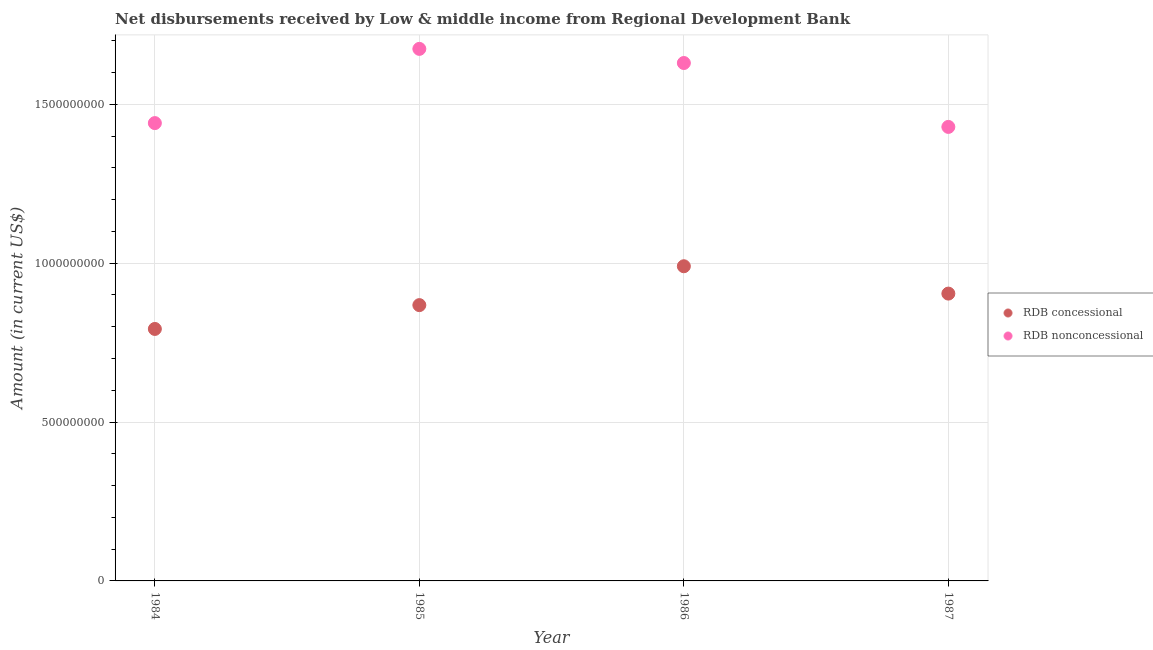How many different coloured dotlines are there?
Ensure brevity in your answer.  2. What is the net concessional disbursements from rdb in 1986?
Your response must be concise. 9.90e+08. Across all years, what is the maximum net concessional disbursements from rdb?
Your answer should be very brief. 9.90e+08. Across all years, what is the minimum net concessional disbursements from rdb?
Keep it short and to the point. 7.93e+08. In which year was the net concessional disbursements from rdb minimum?
Your response must be concise. 1984. What is the total net non concessional disbursements from rdb in the graph?
Your answer should be compact. 6.17e+09. What is the difference between the net non concessional disbursements from rdb in 1984 and that in 1985?
Provide a short and direct response. -2.34e+08. What is the difference between the net non concessional disbursements from rdb in 1987 and the net concessional disbursements from rdb in 1984?
Give a very brief answer. 6.36e+08. What is the average net non concessional disbursements from rdb per year?
Provide a short and direct response. 1.54e+09. In the year 1984, what is the difference between the net concessional disbursements from rdb and net non concessional disbursements from rdb?
Make the answer very short. -6.48e+08. What is the ratio of the net concessional disbursements from rdb in 1984 to that in 1986?
Give a very brief answer. 0.8. Is the difference between the net concessional disbursements from rdb in 1984 and 1987 greater than the difference between the net non concessional disbursements from rdb in 1984 and 1987?
Ensure brevity in your answer.  No. What is the difference between the highest and the second highest net non concessional disbursements from rdb?
Make the answer very short. 4.45e+07. What is the difference between the highest and the lowest net concessional disbursements from rdb?
Make the answer very short. 1.97e+08. Is the net non concessional disbursements from rdb strictly greater than the net concessional disbursements from rdb over the years?
Ensure brevity in your answer.  Yes. Is the net non concessional disbursements from rdb strictly less than the net concessional disbursements from rdb over the years?
Give a very brief answer. No. How many dotlines are there?
Make the answer very short. 2. What is the difference between two consecutive major ticks on the Y-axis?
Provide a succinct answer. 5.00e+08. Are the values on the major ticks of Y-axis written in scientific E-notation?
Make the answer very short. No. Does the graph contain grids?
Offer a terse response. Yes. Where does the legend appear in the graph?
Ensure brevity in your answer.  Center right. What is the title of the graph?
Ensure brevity in your answer.  Net disbursements received by Low & middle income from Regional Development Bank. What is the label or title of the X-axis?
Offer a terse response. Year. What is the label or title of the Y-axis?
Offer a terse response. Amount (in current US$). What is the Amount (in current US$) in RDB concessional in 1984?
Ensure brevity in your answer.  7.93e+08. What is the Amount (in current US$) in RDB nonconcessional in 1984?
Your response must be concise. 1.44e+09. What is the Amount (in current US$) of RDB concessional in 1985?
Make the answer very short. 8.68e+08. What is the Amount (in current US$) in RDB nonconcessional in 1985?
Make the answer very short. 1.67e+09. What is the Amount (in current US$) in RDB concessional in 1986?
Offer a very short reply. 9.90e+08. What is the Amount (in current US$) in RDB nonconcessional in 1986?
Offer a very short reply. 1.63e+09. What is the Amount (in current US$) in RDB concessional in 1987?
Give a very brief answer. 9.04e+08. What is the Amount (in current US$) of RDB nonconcessional in 1987?
Your response must be concise. 1.43e+09. Across all years, what is the maximum Amount (in current US$) of RDB concessional?
Ensure brevity in your answer.  9.90e+08. Across all years, what is the maximum Amount (in current US$) in RDB nonconcessional?
Provide a short and direct response. 1.67e+09. Across all years, what is the minimum Amount (in current US$) in RDB concessional?
Your answer should be very brief. 7.93e+08. Across all years, what is the minimum Amount (in current US$) in RDB nonconcessional?
Your answer should be compact. 1.43e+09. What is the total Amount (in current US$) in RDB concessional in the graph?
Ensure brevity in your answer.  3.56e+09. What is the total Amount (in current US$) in RDB nonconcessional in the graph?
Give a very brief answer. 6.17e+09. What is the difference between the Amount (in current US$) of RDB concessional in 1984 and that in 1985?
Give a very brief answer. -7.50e+07. What is the difference between the Amount (in current US$) in RDB nonconcessional in 1984 and that in 1985?
Offer a terse response. -2.34e+08. What is the difference between the Amount (in current US$) of RDB concessional in 1984 and that in 1986?
Provide a short and direct response. -1.97e+08. What is the difference between the Amount (in current US$) of RDB nonconcessional in 1984 and that in 1986?
Keep it short and to the point. -1.89e+08. What is the difference between the Amount (in current US$) in RDB concessional in 1984 and that in 1987?
Keep it short and to the point. -1.11e+08. What is the difference between the Amount (in current US$) in RDB nonconcessional in 1984 and that in 1987?
Your answer should be compact. 1.20e+07. What is the difference between the Amount (in current US$) of RDB concessional in 1985 and that in 1986?
Keep it short and to the point. -1.22e+08. What is the difference between the Amount (in current US$) of RDB nonconcessional in 1985 and that in 1986?
Give a very brief answer. 4.45e+07. What is the difference between the Amount (in current US$) in RDB concessional in 1985 and that in 1987?
Keep it short and to the point. -3.63e+07. What is the difference between the Amount (in current US$) in RDB nonconcessional in 1985 and that in 1987?
Offer a very short reply. 2.46e+08. What is the difference between the Amount (in current US$) in RDB concessional in 1986 and that in 1987?
Keep it short and to the point. 8.61e+07. What is the difference between the Amount (in current US$) in RDB nonconcessional in 1986 and that in 1987?
Keep it short and to the point. 2.01e+08. What is the difference between the Amount (in current US$) in RDB concessional in 1984 and the Amount (in current US$) in RDB nonconcessional in 1985?
Offer a very short reply. -8.81e+08. What is the difference between the Amount (in current US$) of RDB concessional in 1984 and the Amount (in current US$) of RDB nonconcessional in 1986?
Keep it short and to the point. -8.37e+08. What is the difference between the Amount (in current US$) in RDB concessional in 1984 and the Amount (in current US$) in RDB nonconcessional in 1987?
Offer a very short reply. -6.36e+08. What is the difference between the Amount (in current US$) of RDB concessional in 1985 and the Amount (in current US$) of RDB nonconcessional in 1986?
Make the answer very short. -7.62e+08. What is the difference between the Amount (in current US$) in RDB concessional in 1985 and the Amount (in current US$) in RDB nonconcessional in 1987?
Your answer should be very brief. -5.61e+08. What is the difference between the Amount (in current US$) in RDB concessional in 1986 and the Amount (in current US$) in RDB nonconcessional in 1987?
Keep it short and to the point. -4.38e+08. What is the average Amount (in current US$) of RDB concessional per year?
Your answer should be compact. 8.89e+08. What is the average Amount (in current US$) of RDB nonconcessional per year?
Provide a succinct answer. 1.54e+09. In the year 1984, what is the difference between the Amount (in current US$) in RDB concessional and Amount (in current US$) in RDB nonconcessional?
Provide a succinct answer. -6.48e+08. In the year 1985, what is the difference between the Amount (in current US$) in RDB concessional and Amount (in current US$) in RDB nonconcessional?
Your response must be concise. -8.06e+08. In the year 1986, what is the difference between the Amount (in current US$) in RDB concessional and Amount (in current US$) in RDB nonconcessional?
Offer a very short reply. -6.40e+08. In the year 1987, what is the difference between the Amount (in current US$) of RDB concessional and Amount (in current US$) of RDB nonconcessional?
Your response must be concise. -5.25e+08. What is the ratio of the Amount (in current US$) in RDB concessional in 1984 to that in 1985?
Your answer should be compact. 0.91. What is the ratio of the Amount (in current US$) in RDB nonconcessional in 1984 to that in 1985?
Your response must be concise. 0.86. What is the ratio of the Amount (in current US$) of RDB concessional in 1984 to that in 1986?
Keep it short and to the point. 0.8. What is the ratio of the Amount (in current US$) in RDB nonconcessional in 1984 to that in 1986?
Keep it short and to the point. 0.88. What is the ratio of the Amount (in current US$) of RDB concessional in 1984 to that in 1987?
Make the answer very short. 0.88. What is the ratio of the Amount (in current US$) of RDB nonconcessional in 1984 to that in 1987?
Offer a terse response. 1.01. What is the ratio of the Amount (in current US$) in RDB concessional in 1985 to that in 1986?
Offer a very short reply. 0.88. What is the ratio of the Amount (in current US$) of RDB nonconcessional in 1985 to that in 1986?
Keep it short and to the point. 1.03. What is the ratio of the Amount (in current US$) in RDB concessional in 1985 to that in 1987?
Provide a succinct answer. 0.96. What is the ratio of the Amount (in current US$) of RDB nonconcessional in 1985 to that in 1987?
Provide a succinct answer. 1.17. What is the ratio of the Amount (in current US$) in RDB concessional in 1986 to that in 1987?
Offer a terse response. 1.1. What is the ratio of the Amount (in current US$) in RDB nonconcessional in 1986 to that in 1987?
Make the answer very short. 1.14. What is the difference between the highest and the second highest Amount (in current US$) of RDB concessional?
Your answer should be very brief. 8.61e+07. What is the difference between the highest and the second highest Amount (in current US$) of RDB nonconcessional?
Offer a terse response. 4.45e+07. What is the difference between the highest and the lowest Amount (in current US$) in RDB concessional?
Offer a very short reply. 1.97e+08. What is the difference between the highest and the lowest Amount (in current US$) in RDB nonconcessional?
Give a very brief answer. 2.46e+08. 